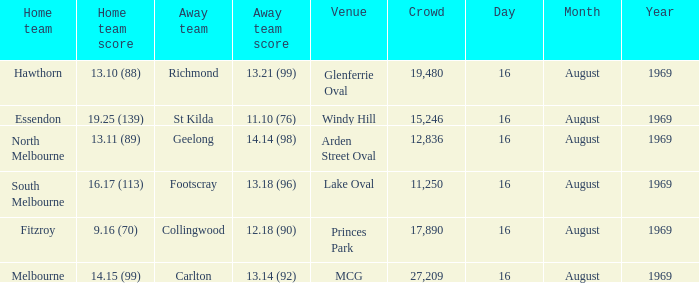Who was home at Princes Park? 9.16 (70). 